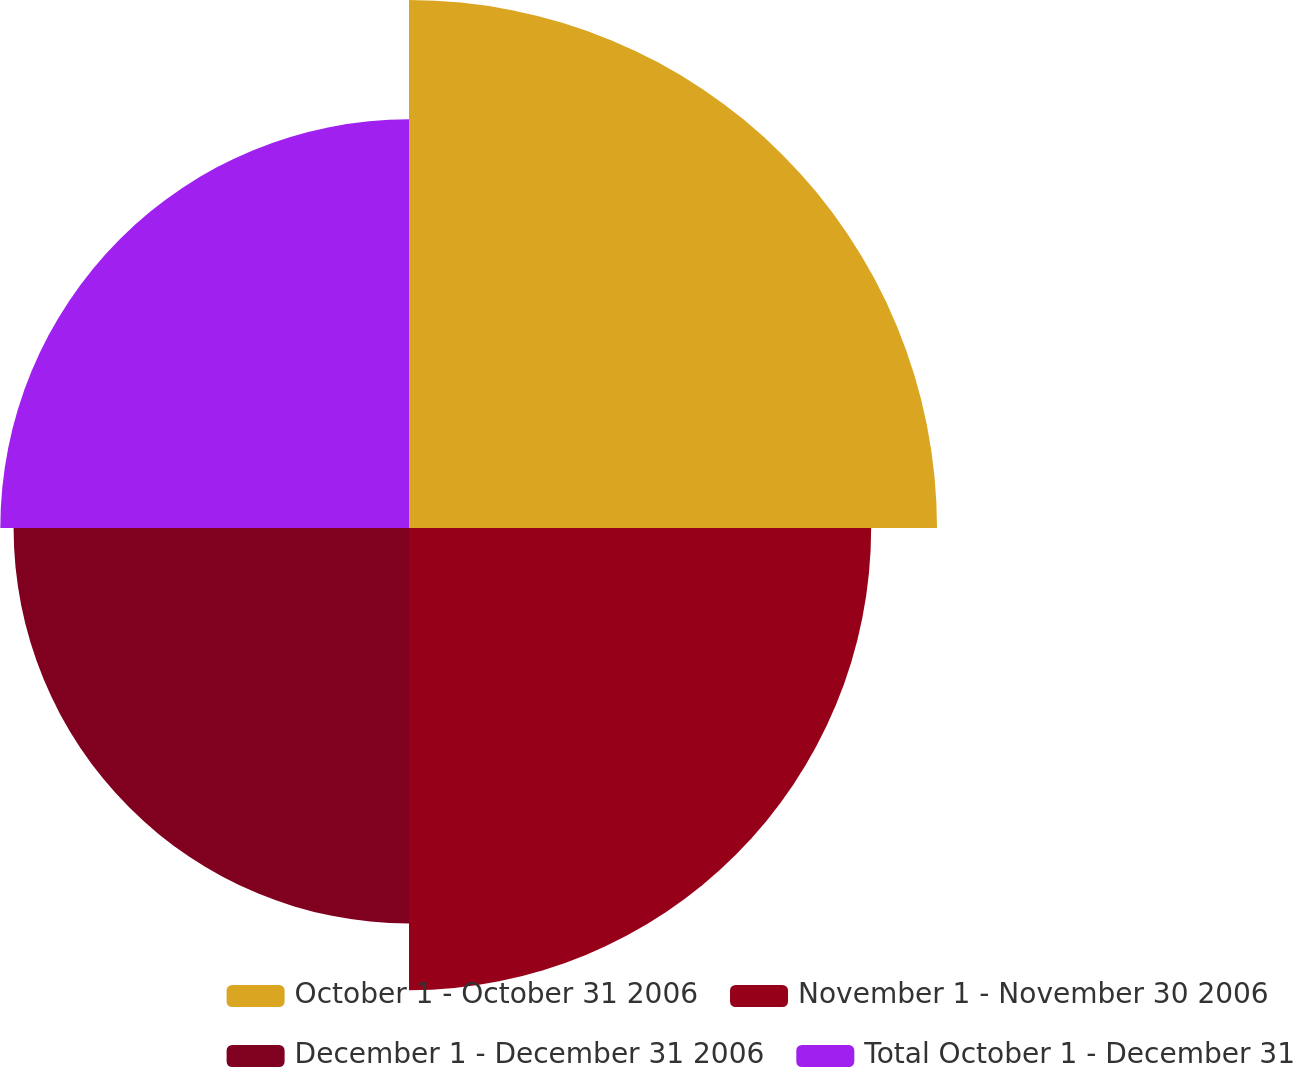<chart> <loc_0><loc_0><loc_500><loc_500><pie_chart><fcel>October 1 - October 31 2006<fcel>November 1 - November 30 2006<fcel>December 1 - December 31 2006<fcel>Total October 1 - December 31<nl><fcel>29.43%<fcel>25.76%<fcel>22.04%<fcel>22.78%<nl></chart> 